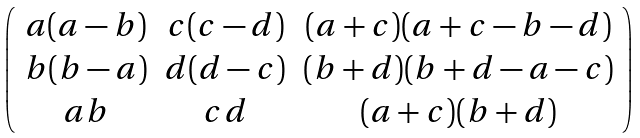<formula> <loc_0><loc_0><loc_500><loc_500>\left ( \begin{array} { c c c } a ( a - b ) & c ( c - d ) & ( a + c ) ( a + c - b - d ) \\ b ( b - a ) & d ( d - c ) & ( b + d ) ( b + d - a - c ) \\ a b & c d & ( a + c ) ( b + d ) \\ \end{array} \right )</formula> 